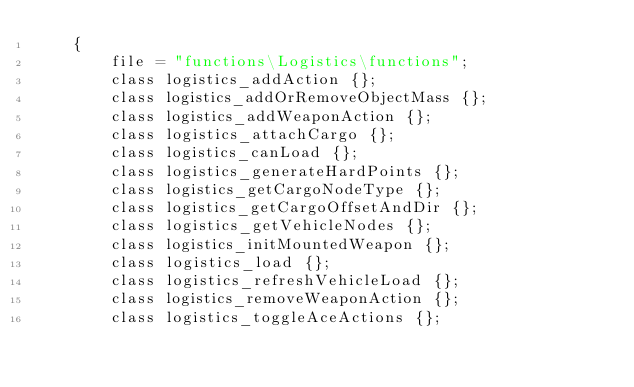Convert code to text. <code><loc_0><loc_0><loc_500><loc_500><_C++_>    {
        file = "functions\Logistics\functions";
        class logistics_addAction {};
        class logistics_addOrRemoveObjectMass {};
        class logistics_addWeaponAction {};
        class logistics_attachCargo {};
        class logistics_canLoad {};
        class logistics_generateHardPoints {};
        class logistics_getCargoNodeType {};
        class logistics_getCargoOffsetAndDir {};
        class logistics_getVehicleNodes {};
        class logistics_initMountedWeapon {};
        class logistics_load {};
        class logistics_refreshVehicleLoad {};
        class logistics_removeWeaponAction {};
        class logistics_toggleAceActions {};</code> 